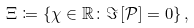Convert formula to latex. <formula><loc_0><loc_0><loc_500><loc_500>\Xi \coloneqq \left \{ \chi \in \mathbb { R } \colon \Im \left [ \mathcal { P } \right ] = 0 \right \} ,</formula> 